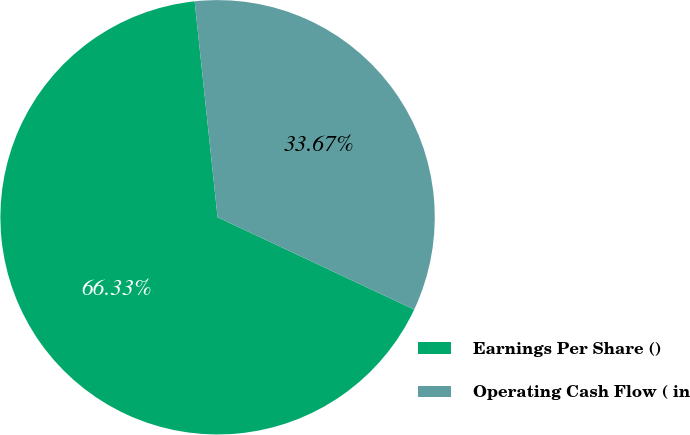<chart> <loc_0><loc_0><loc_500><loc_500><pie_chart><fcel>Earnings Per Share ()<fcel>Operating Cash Flow ( in<nl><fcel>66.33%<fcel>33.67%<nl></chart> 